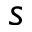Convert formula to latex. <formula><loc_0><loc_0><loc_500><loc_500>s</formula> 